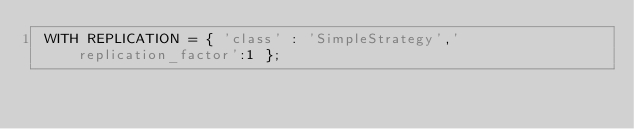Convert code to text. <code><loc_0><loc_0><loc_500><loc_500><_SQL_> WITH REPLICATION = { 'class' : 'SimpleStrategy','replication_factor':1 };</code> 